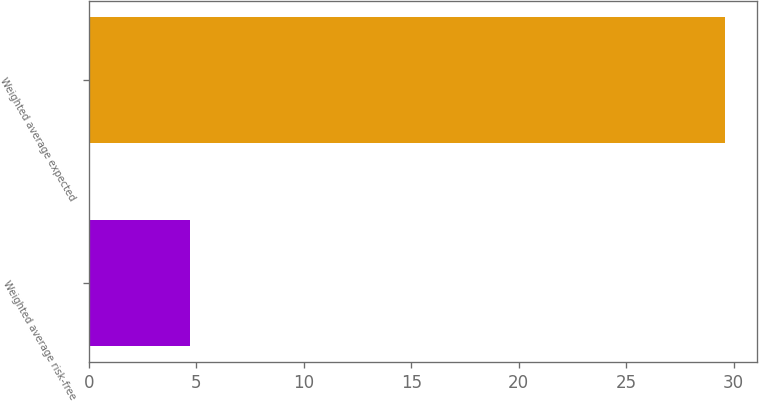<chart> <loc_0><loc_0><loc_500><loc_500><bar_chart><fcel>Weighted average risk-free<fcel>Weighted average expected<nl><fcel>4.72<fcel>29.6<nl></chart> 